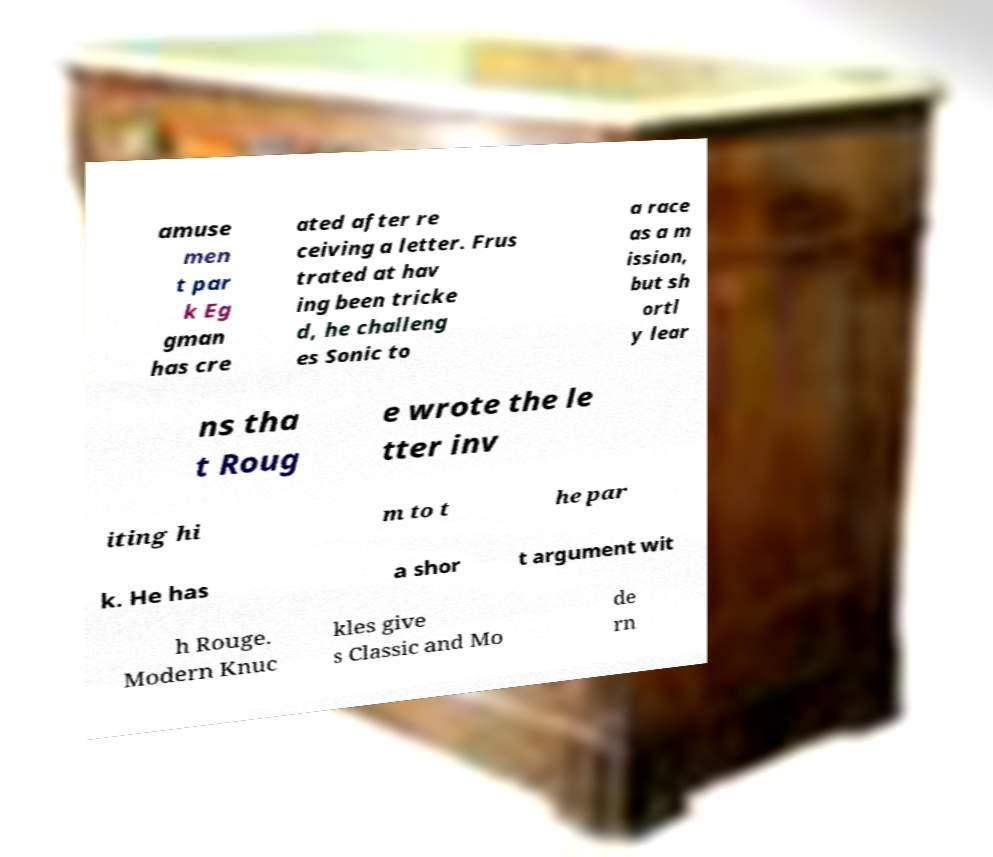What messages or text are displayed in this image? I need them in a readable, typed format. amuse men t par k Eg gman has cre ated after re ceiving a letter. Frus trated at hav ing been tricke d, he challeng es Sonic to a race as a m ission, but sh ortl y lear ns tha t Roug e wrote the le tter inv iting hi m to t he par k. He has a shor t argument wit h Rouge. Modern Knuc kles give s Classic and Mo de rn 